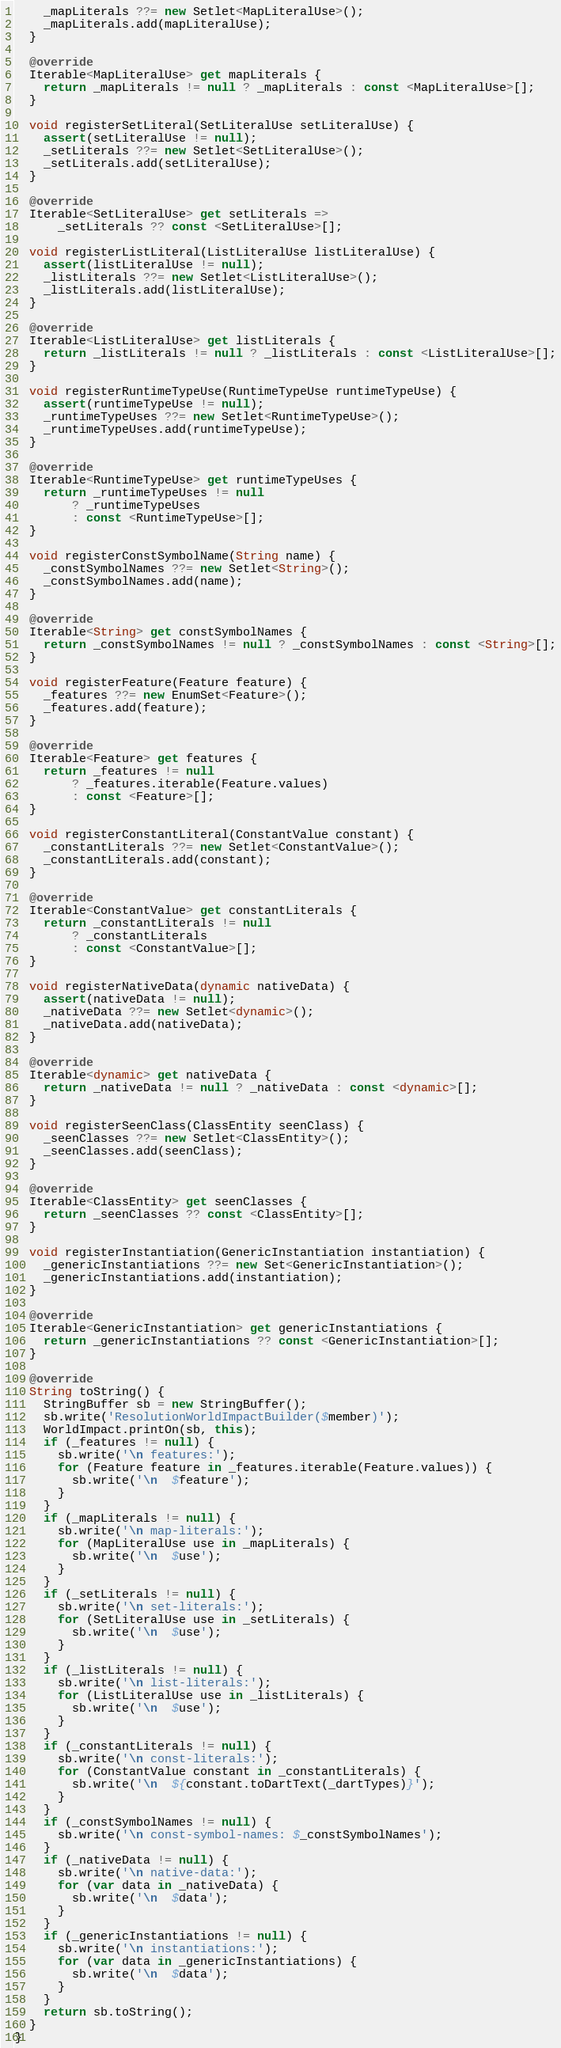Convert code to text. <code><loc_0><loc_0><loc_500><loc_500><_Dart_>    _mapLiterals ??= new Setlet<MapLiteralUse>();
    _mapLiterals.add(mapLiteralUse);
  }

  @override
  Iterable<MapLiteralUse> get mapLiterals {
    return _mapLiterals != null ? _mapLiterals : const <MapLiteralUse>[];
  }

  void registerSetLiteral(SetLiteralUse setLiteralUse) {
    assert(setLiteralUse != null);
    _setLiterals ??= new Setlet<SetLiteralUse>();
    _setLiterals.add(setLiteralUse);
  }

  @override
  Iterable<SetLiteralUse> get setLiterals =>
      _setLiterals ?? const <SetLiteralUse>[];

  void registerListLiteral(ListLiteralUse listLiteralUse) {
    assert(listLiteralUse != null);
    _listLiterals ??= new Setlet<ListLiteralUse>();
    _listLiterals.add(listLiteralUse);
  }

  @override
  Iterable<ListLiteralUse> get listLiterals {
    return _listLiterals != null ? _listLiterals : const <ListLiteralUse>[];
  }

  void registerRuntimeTypeUse(RuntimeTypeUse runtimeTypeUse) {
    assert(runtimeTypeUse != null);
    _runtimeTypeUses ??= new Setlet<RuntimeTypeUse>();
    _runtimeTypeUses.add(runtimeTypeUse);
  }

  @override
  Iterable<RuntimeTypeUse> get runtimeTypeUses {
    return _runtimeTypeUses != null
        ? _runtimeTypeUses
        : const <RuntimeTypeUse>[];
  }

  void registerConstSymbolName(String name) {
    _constSymbolNames ??= new Setlet<String>();
    _constSymbolNames.add(name);
  }

  @override
  Iterable<String> get constSymbolNames {
    return _constSymbolNames != null ? _constSymbolNames : const <String>[];
  }

  void registerFeature(Feature feature) {
    _features ??= new EnumSet<Feature>();
    _features.add(feature);
  }

  @override
  Iterable<Feature> get features {
    return _features != null
        ? _features.iterable(Feature.values)
        : const <Feature>[];
  }

  void registerConstantLiteral(ConstantValue constant) {
    _constantLiterals ??= new Setlet<ConstantValue>();
    _constantLiterals.add(constant);
  }

  @override
  Iterable<ConstantValue> get constantLiterals {
    return _constantLiterals != null
        ? _constantLiterals
        : const <ConstantValue>[];
  }

  void registerNativeData(dynamic nativeData) {
    assert(nativeData != null);
    _nativeData ??= new Setlet<dynamic>();
    _nativeData.add(nativeData);
  }

  @override
  Iterable<dynamic> get nativeData {
    return _nativeData != null ? _nativeData : const <dynamic>[];
  }

  void registerSeenClass(ClassEntity seenClass) {
    _seenClasses ??= new Setlet<ClassEntity>();
    _seenClasses.add(seenClass);
  }

  @override
  Iterable<ClassEntity> get seenClasses {
    return _seenClasses ?? const <ClassEntity>[];
  }

  void registerInstantiation(GenericInstantiation instantiation) {
    _genericInstantiations ??= new Set<GenericInstantiation>();
    _genericInstantiations.add(instantiation);
  }

  @override
  Iterable<GenericInstantiation> get genericInstantiations {
    return _genericInstantiations ?? const <GenericInstantiation>[];
  }

  @override
  String toString() {
    StringBuffer sb = new StringBuffer();
    sb.write('ResolutionWorldImpactBuilder($member)');
    WorldImpact.printOn(sb, this);
    if (_features != null) {
      sb.write('\n features:');
      for (Feature feature in _features.iterable(Feature.values)) {
        sb.write('\n  $feature');
      }
    }
    if (_mapLiterals != null) {
      sb.write('\n map-literals:');
      for (MapLiteralUse use in _mapLiterals) {
        sb.write('\n  $use');
      }
    }
    if (_setLiterals != null) {
      sb.write('\n set-literals:');
      for (SetLiteralUse use in _setLiterals) {
        sb.write('\n  $use');
      }
    }
    if (_listLiterals != null) {
      sb.write('\n list-literals:');
      for (ListLiteralUse use in _listLiterals) {
        sb.write('\n  $use');
      }
    }
    if (_constantLiterals != null) {
      sb.write('\n const-literals:');
      for (ConstantValue constant in _constantLiterals) {
        sb.write('\n  ${constant.toDartText(_dartTypes)}');
      }
    }
    if (_constSymbolNames != null) {
      sb.write('\n const-symbol-names: $_constSymbolNames');
    }
    if (_nativeData != null) {
      sb.write('\n native-data:');
      for (var data in _nativeData) {
        sb.write('\n  $data');
      }
    }
    if (_genericInstantiations != null) {
      sb.write('\n instantiations:');
      for (var data in _genericInstantiations) {
        sb.write('\n  $data');
      }
    }
    return sb.toString();
  }
}
</code> 